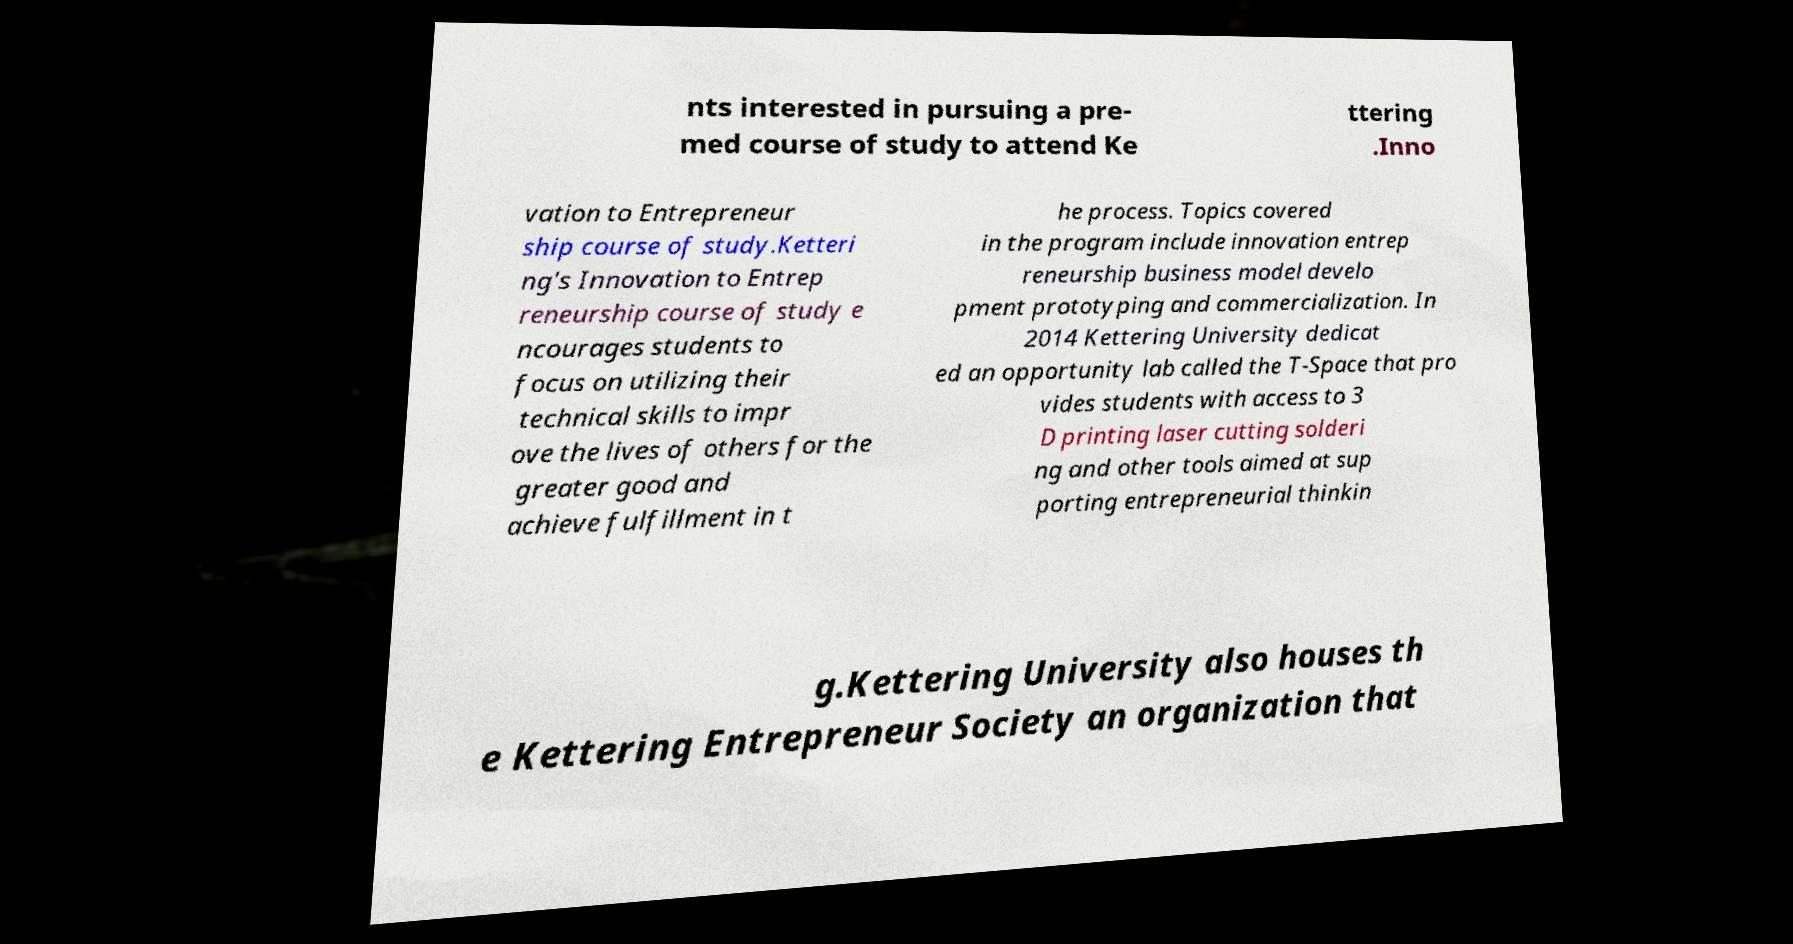Can you accurately transcribe the text from the provided image for me? nts interested in pursuing a pre- med course of study to attend Ke ttering .Inno vation to Entrepreneur ship course of study.Ketteri ng's Innovation to Entrep reneurship course of study e ncourages students to focus on utilizing their technical skills to impr ove the lives of others for the greater good and achieve fulfillment in t he process. Topics covered in the program include innovation entrep reneurship business model develo pment prototyping and commercialization. In 2014 Kettering University dedicat ed an opportunity lab called the T-Space that pro vides students with access to 3 D printing laser cutting solderi ng and other tools aimed at sup porting entrepreneurial thinkin g.Kettering University also houses th e Kettering Entrepreneur Society an organization that 